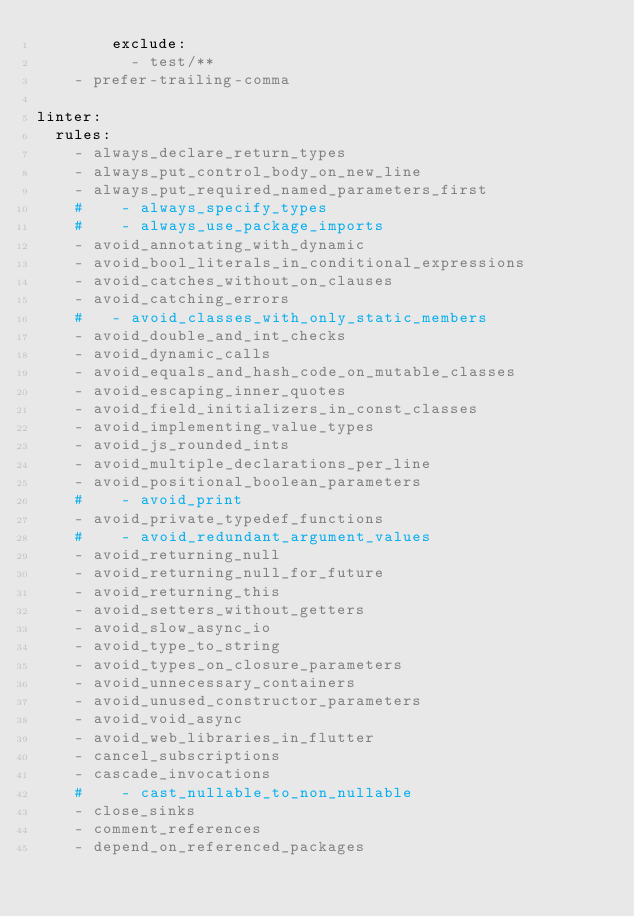<code> <loc_0><loc_0><loc_500><loc_500><_YAML_>        exclude:
          - test/**
    - prefer-trailing-comma

linter:
  rules:
    - always_declare_return_types
    - always_put_control_body_on_new_line
    - always_put_required_named_parameters_first
    #    - always_specify_types
    #    - always_use_package_imports
    - avoid_annotating_with_dynamic
    - avoid_bool_literals_in_conditional_expressions
    - avoid_catches_without_on_clauses
    - avoid_catching_errors
    #   - avoid_classes_with_only_static_members
    - avoid_double_and_int_checks
    - avoid_dynamic_calls
    - avoid_equals_and_hash_code_on_mutable_classes
    - avoid_escaping_inner_quotes
    - avoid_field_initializers_in_const_classes
    - avoid_implementing_value_types
    - avoid_js_rounded_ints
    - avoid_multiple_declarations_per_line
    - avoid_positional_boolean_parameters
    #    - avoid_print
    - avoid_private_typedef_functions
    #    - avoid_redundant_argument_values
    - avoid_returning_null
    - avoid_returning_null_for_future
    - avoid_returning_this
    - avoid_setters_without_getters
    - avoid_slow_async_io
    - avoid_type_to_string
    - avoid_types_on_closure_parameters
    - avoid_unnecessary_containers
    - avoid_unused_constructor_parameters
    - avoid_void_async
    - avoid_web_libraries_in_flutter
    - cancel_subscriptions
    - cascade_invocations
    #    - cast_nullable_to_non_nullable
    - close_sinks
    - comment_references
    - depend_on_referenced_packages</code> 